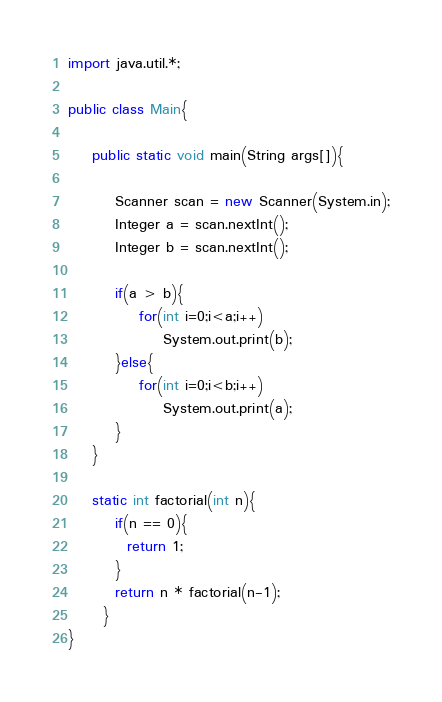<code> <loc_0><loc_0><loc_500><loc_500><_Java_>import java.util.*;

public class Main{

    public static void main(String args[]){

        Scanner scan = new Scanner(System.in);
        Integer a = scan.nextInt();
        Integer b = scan.nextInt();

        if(a > b){
            for(int i=0;i<a;i++)
                System.out.print(b);
        }else{
            for(int i=0;i<b;i++)
                System.out.print(a);
        }
    }

    static int factorial(int n){
        if(n == 0){
          return 1;
        }
        return n * factorial(n-1);
      }
}
</code> 